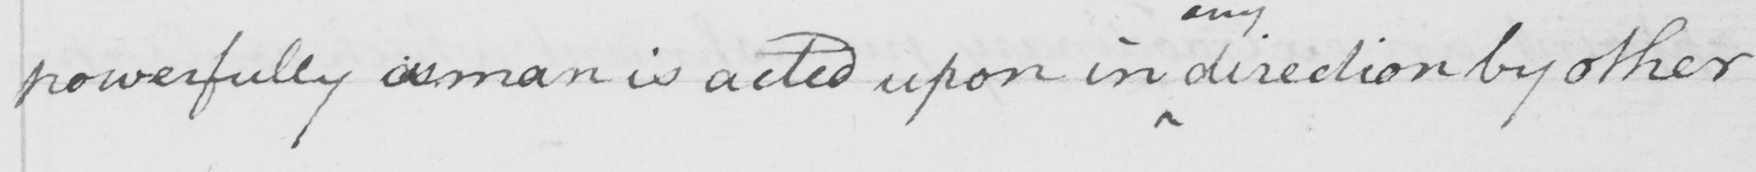What is written in this line of handwriting? powerfully a man is acted upon in direction by other 